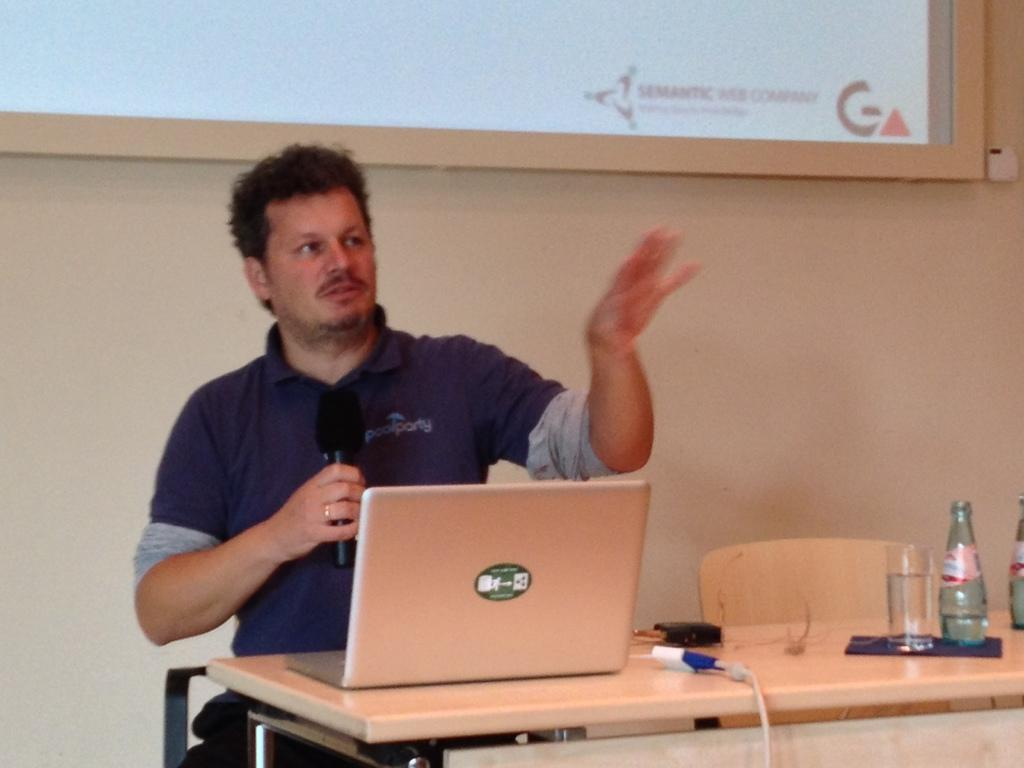Provide a one-sentence caption for the provided image. a man next to an image with the word semantic on it. 